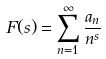Convert formula to latex. <formula><loc_0><loc_0><loc_500><loc_500>F ( s ) = \sum _ { n = 1 } ^ { \infty } \frac { a _ { n } } { n ^ { s } }</formula> 